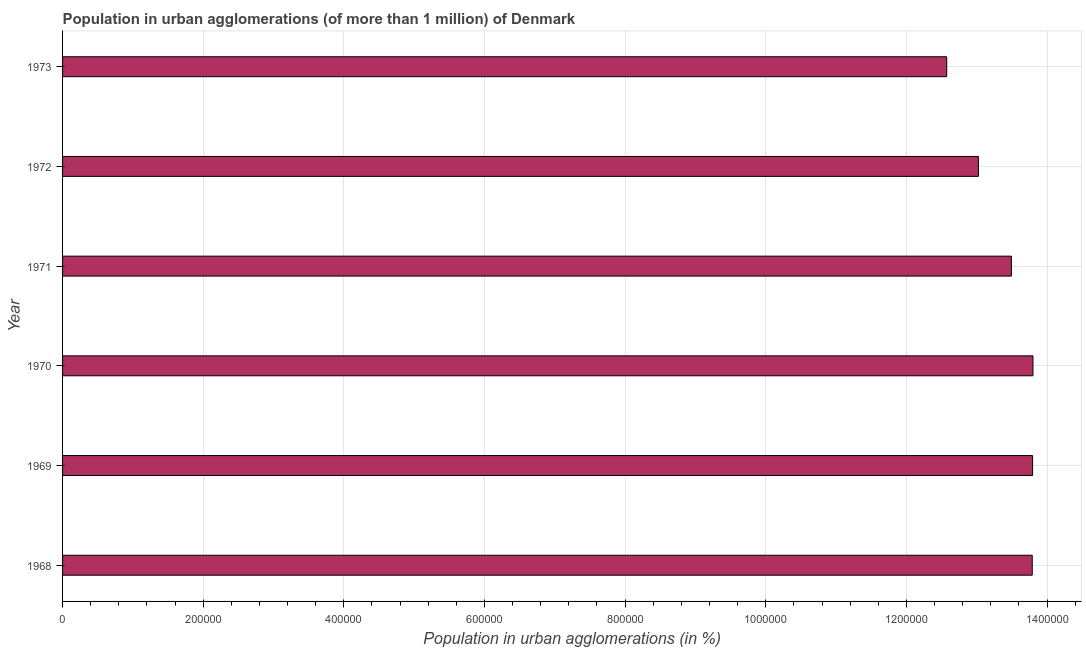Does the graph contain any zero values?
Ensure brevity in your answer.  No. Does the graph contain grids?
Keep it short and to the point. Yes. What is the title of the graph?
Offer a very short reply. Population in urban agglomerations (of more than 1 million) of Denmark. What is the label or title of the X-axis?
Ensure brevity in your answer.  Population in urban agglomerations (in %). What is the population in urban agglomerations in 1973?
Give a very brief answer. 1.26e+06. Across all years, what is the maximum population in urban agglomerations?
Offer a very short reply. 1.38e+06. Across all years, what is the minimum population in urban agglomerations?
Your answer should be very brief. 1.26e+06. In which year was the population in urban agglomerations minimum?
Give a very brief answer. 1973. What is the sum of the population in urban agglomerations?
Ensure brevity in your answer.  8.05e+06. What is the difference between the population in urban agglomerations in 1969 and 1973?
Offer a terse response. 1.22e+05. What is the average population in urban agglomerations per year?
Keep it short and to the point. 1.34e+06. What is the median population in urban agglomerations?
Offer a terse response. 1.36e+06. In how many years, is the population in urban agglomerations greater than 1080000 %?
Make the answer very short. 6. Do a majority of the years between 1971 and 1970 (inclusive) have population in urban agglomerations greater than 1000000 %?
Your answer should be compact. No. What is the ratio of the population in urban agglomerations in 1971 to that in 1972?
Make the answer very short. 1.04. Is the population in urban agglomerations in 1968 less than that in 1973?
Ensure brevity in your answer.  No. What is the difference between the highest and the second highest population in urban agglomerations?
Offer a terse response. 509. Is the sum of the population in urban agglomerations in 1969 and 1970 greater than the maximum population in urban agglomerations across all years?
Offer a terse response. Yes. What is the difference between the highest and the lowest population in urban agglomerations?
Provide a short and direct response. 1.23e+05. In how many years, is the population in urban agglomerations greater than the average population in urban agglomerations taken over all years?
Your answer should be compact. 4. Are all the bars in the graph horizontal?
Your response must be concise. Yes. What is the difference between two consecutive major ticks on the X-axis?
Provide a succinct answer. 2.00e+05. Are the values on the major ticks of X-axis written in scientific E-notation?
Your answer should be compact. No. What is the Population in urban agglomerations (in %) of 1968?
Offer a very short reply. 1.38e+06. What is the Population in urban agglomerations (in %) in 1969?
Make the answer very short. 1.38e+06. What is the Population in urban agglomerations (in %) in 1970?
Offer a very short reply. 1.38e+06. What is the Population in urban agglomerations (in %) in 1971?
Provide a short and direct response. 1.35e+06. What is the Population in urban agglomerations (in %) of 1972?
Ensure brevity in your answer.  1.30e+06. What is the Population in urban agglomerations (in %) in 1973?
Provide a succinct answer. 1.26e+06. What is the difference between the Population in urban agglomerations (in %) in 1968 and 1969?
Provide a short and direct response. -507. What is the difference between the Population in urban agglomerations (in %) in 1968 and 1970?
Make the answer very short. -1016. What is the difference between the Population in urban agglomerations (in %) in 1968 and 1971?
Make the answer very short. 2.97e+04. What is the difference between the Population in urban agglomerations (in %) in 1968 and 1972?
Give a very brief answer. 7.65e+04. What is the difference between the Population in urban agglomerations (in %) in 1968 and 1973?
Keep it short and to the point. 1.22e+05. What is the difference between the Population in urban agglomerations (in %) in 1969 and 1970?
Make the answer very short. -509. What is the difference between the Population in urban agglomerations (in %) in 1969 and 1971?
Make the answer very short. 3.02e+04. What is the difference between the Population in urban agglomerations (in %) in 1969 and 1972?
Provide a short and direct response. 7.70e+04. What is the difference between the Population in urban agglomerations (in %) in 1969 and 1973?
Your answer should be compact. 1.22e+05. What is the difference between the Population in urban agglomerations (in %) in 1970 and 1971?
Keep it short and to the point. 3.07e+04. What is the difference between the Population in urban agglomerations (in %) in 1970 and 1972?
Ensure brevity in your answer.  7.76e+04. What is the difference between the Population in urban agglomerations (in %) in 1970 and 1973?
Provide a short and direct response. 1.23e+05. What is the difference between the Population in urban agglomerations (in %) in 1971 and 1972?
Keep it short and to the point. 4.69e+04. What is the difference between the Population in urban agglomerations (in %) in 1971 and 1973?
Ensure brevity in your answer.  9.20e+04. What is the difference between the Population in urban agglomerations (in %) in 1972 and 1973?
Offer a very short reply. 4.51e+04. What is the ratio of the Population in urban agglomerations (in %) in 1968 to that in 1969?
Your answer should be compact. 1. What is the ratio of the Population in urban agglomerations (in %) in 1968 to that in 1970?
Ensure brevity in your answer.  1. What is the ratio of the Population in urban agglomerations (in %) in 1968 to that in 1971?
Your response must be concise. 1.02. What is the ratio of the Population in urban agglomerations (in %) in 1968 to that in 1972?
Offer a terse response. 1.06. What is the ratio of the Population in urban agglomerations (in %) in 1968 to that in 1973?
Your response must be concise. 1.1. What is the ratio of the Population in urban agglomerations (in %) in 1969 to that in 1972?
Offer a terse response. 1.06. What is the ratio of the Population in urban agglomerations (in %) in 1969 to that in 1973?
Your answer should be very brief. 1.1. What is the ratio of the Population in urban agglomerations (in %) in 1970 to that in 1971?
Give a very brief answer. 1.02. What is the ratio of the Population in urban agglomerations (in %) in 1970 to that in 1972?
Give a very brief answer. 1.06. What is the ratio of the Population in urban agglomerations (in %) in 1970 to that in 1973?
Your response must be concise. 1.1. What is the ratio of the Population in urban agglomerations (in %) in 1971 to that in 1972?
Give a very brief answer. 1.04. What is the ratio of the Population in urban agglomerations (in %) in 1971 to that in 1973?
Offer a very short reply. 1.07. What is the ratio of the Population in urban agglomerations (in %) in 1972 to that in 1973?
Keep it short and to the point. 1.04. 